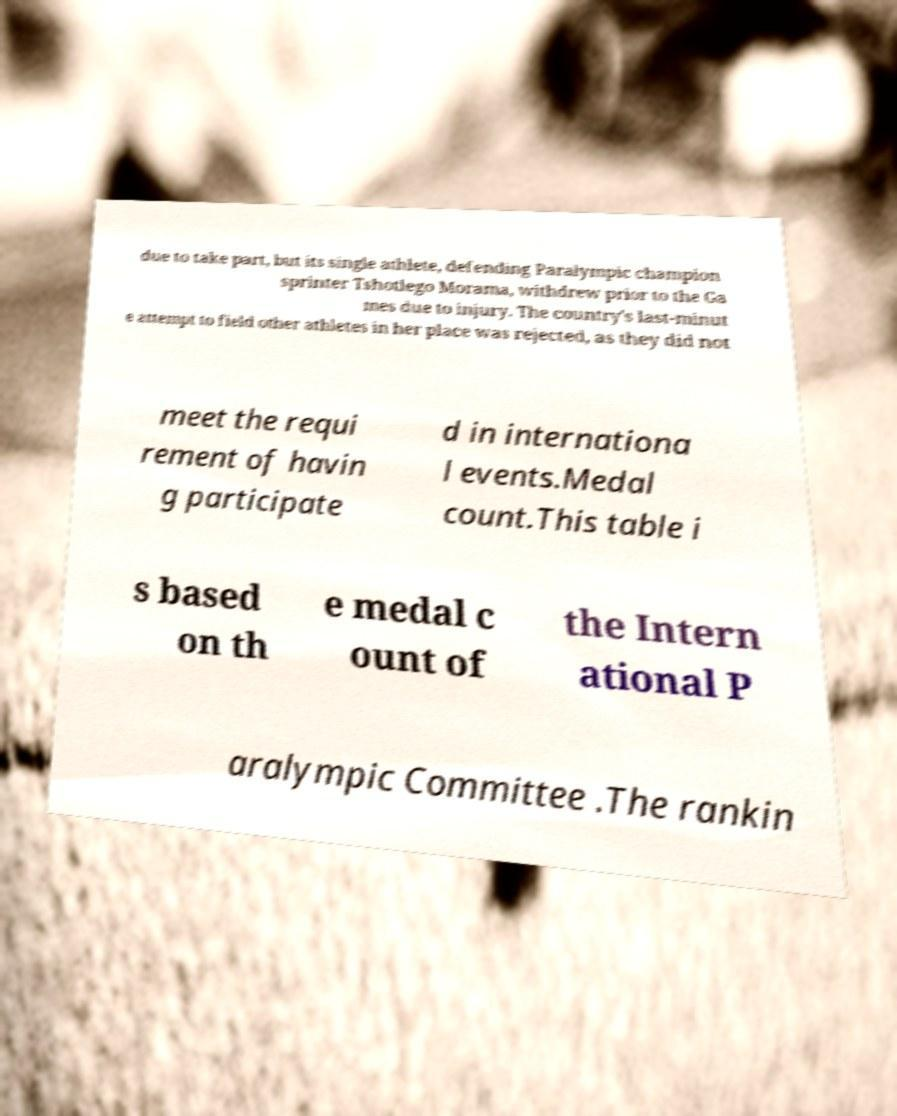Can you read and provide the text displayed in the image?This photo seems to have some interesting text. Can you extract and type it out for me? due to take part, but its single athlete, defending Paralympic champion sprinter Tshotlego Morama, withdrew prior to the Ga mes due to injury. The country's last-minut e attempt to field other athletes in her place was rejected, as they did not meet the requi rement of havin g participate d in internationa l events.Medal count.This table i s based on th e medal c ount of the Intern ational P aralympic Committee .The rankin 